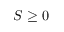Convert formula to latex. <formula><loc_0><loc_0><loc_500><loc_500>S \geq 0</formula> 